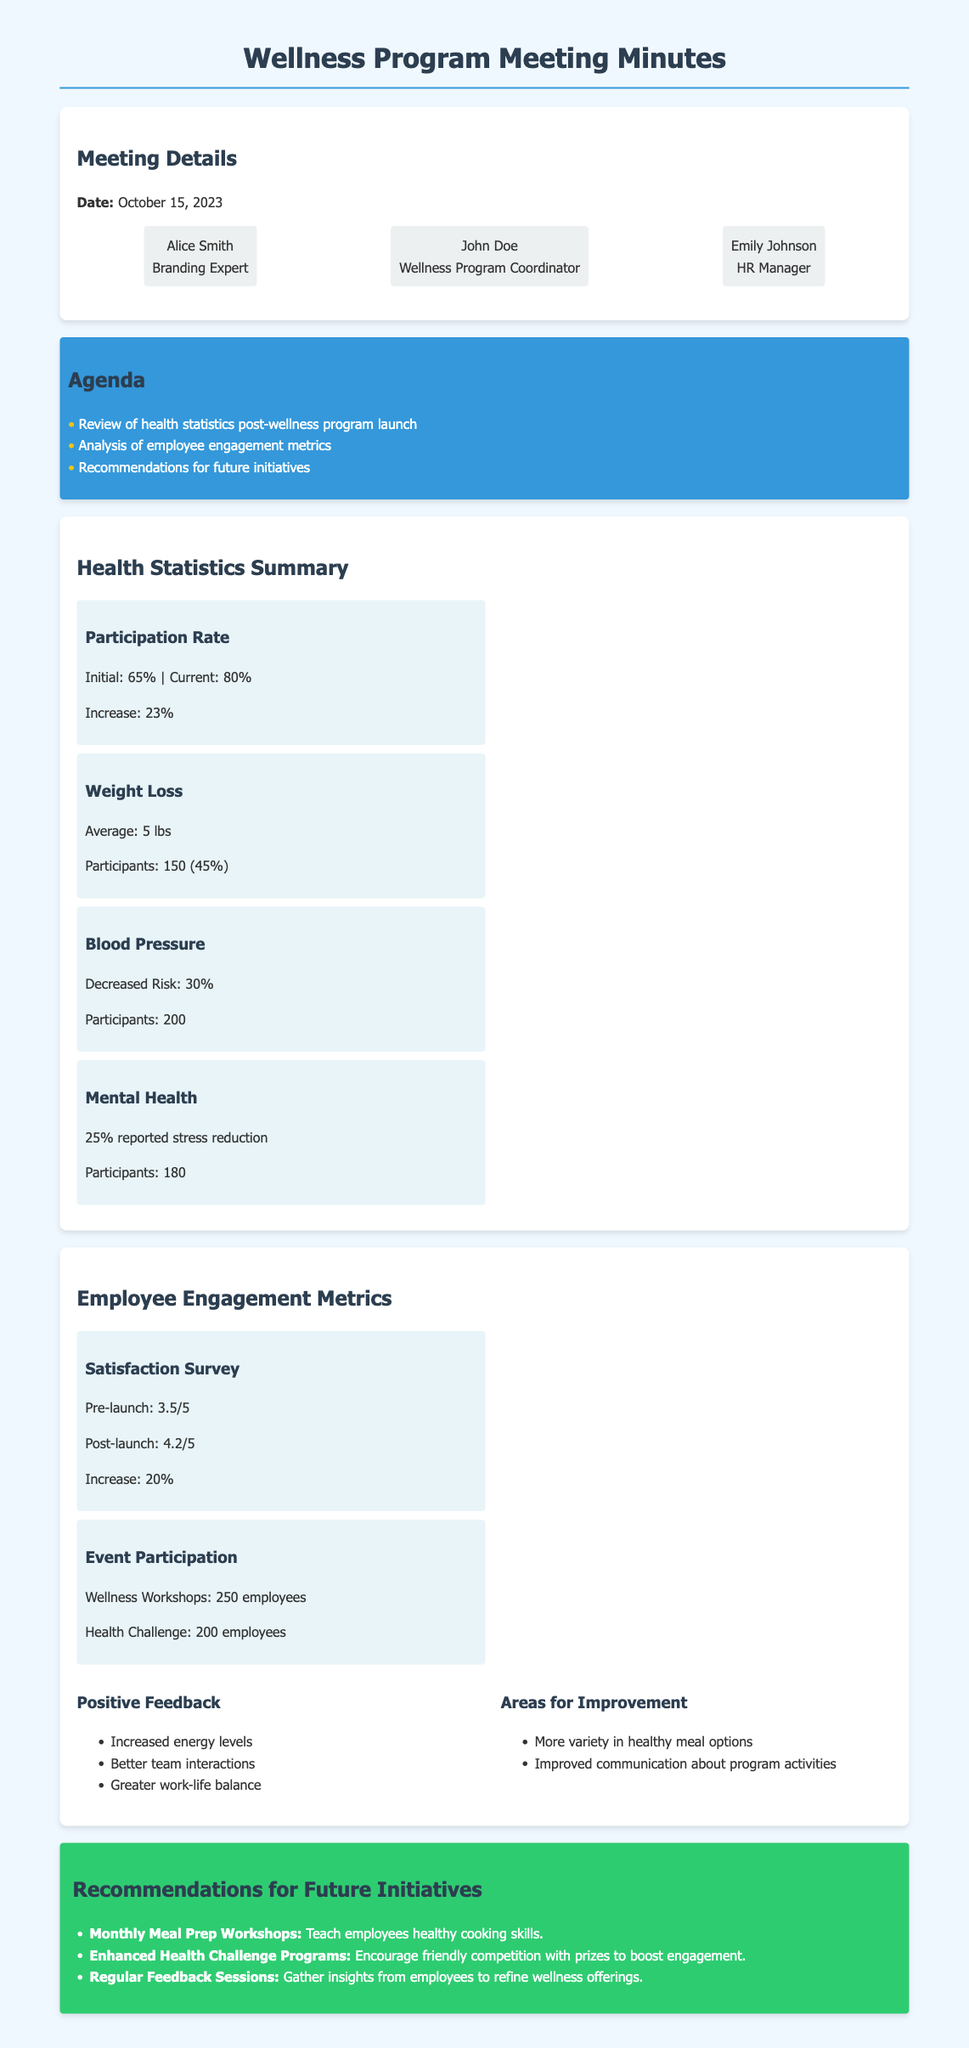What was the date of the meeting? The date of the meeting is mentioned at the beginning of the document.
Answer: October 15, 2023 Who is the Wellness Program Coordinator? The document lists the participants and their roles; one is specifically named as the Wellness Program Coordinator.
Answer: John Doe What was the initial participation rate of the wellness program? The participation rate data includes both initial and current rates.
Answer: 65% What is the average weight loss reported in the statistics? The document provides specific health statistics related to weight loss.
Answer: 5 lbs What increase was observed in the satisfaction survey scores post-launch? The satisfaction survey scores before and after the launch are compared to show the increase.
Answer: 20% How many employees participated in the Health Challenge? The document specifies the number of employees who took part in the Health Challenge under employee engagement metrics.
Answer: 200 employees What is the recommendation for enhancing employee engagement? The document lists recommendations for future initiatives to improve engagement.
Answer: Enhanced Health Challenge Programs What feedback area was indicated for improvement regarding meal options? The document summarizes areas for improvement based on employee feedback regarding meal choices.
Answer: More variety in healthy meal options What percentage of participants reported stress reduction in mental health statistics? The document includes specific percentages regarding mental health improvements post-program launch.
Answer: 25% 